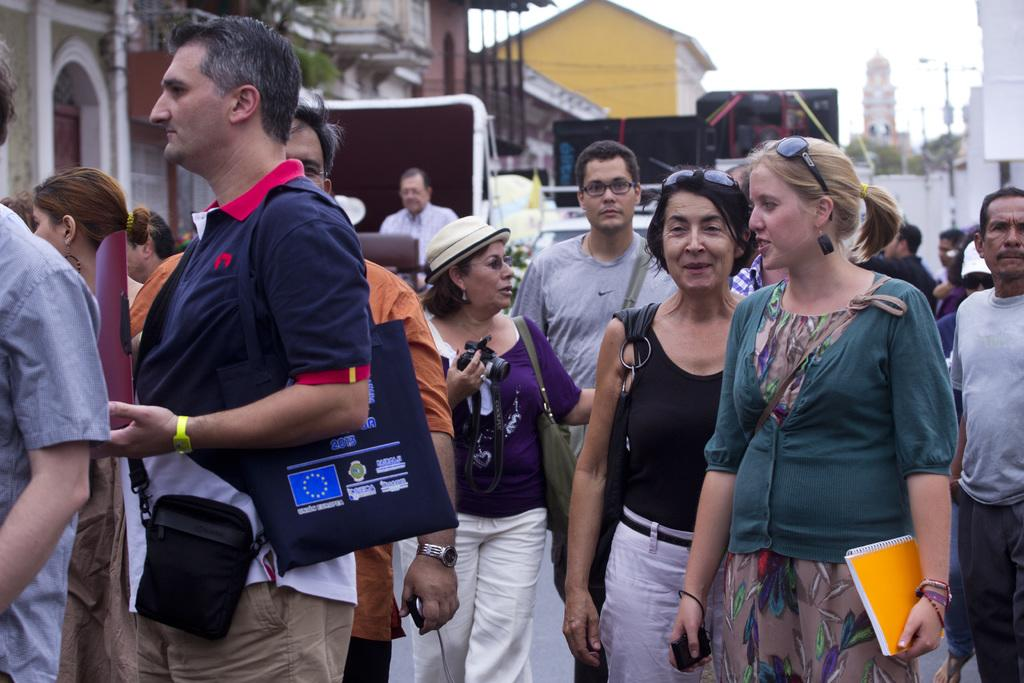What types of people are present in the image? There are men and women in the image. Where are the men and women located? The men and women are on the road. What can be seen in the background of the image? There are buildings and poles in the background of the image. What type of egg is being traded by the men in the image? There is no egg present in the image, nor is there any indication of a trade taking place. 